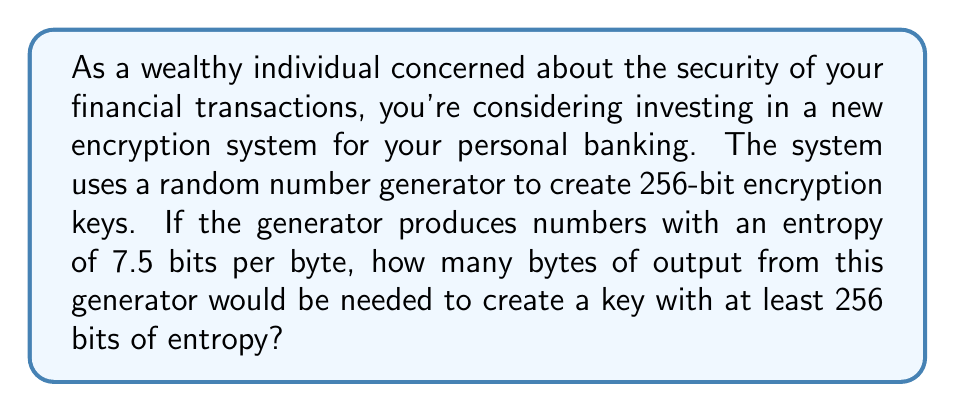Show me your answer to this math problem. Let's approach this step-by-step:

1) First, we need to understand what we're given:
   - We need a key with at least 256 bits of entropy
   - The random number generator produces 7.5 bits of entropy per byte

2) We can set up an equation:
   Let $x$ be the number of bytes we need.
   Then, $7.5x \geq 256$

3) Solving for $x$:
   $$x \geq \frac{256}{7.5} = 34.1333...$$

4) Since we can't use a fractional number of bytes, we need to round up to the next whole number.

5) Therefore, we need 35 bytes to ensure we have at least 256 bits of entropy.

6) To verify:
   $35 * 7.5 = 262.5$ bits of entropy, which is indeed greater than 256.
Answer: 35 bytes 